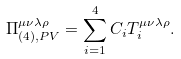<formula> <loc_0><loc_0><loc_500><loc_500>\Pi _ { ( 4 ) , P V } ^ { \mu \nu \lambda \rho } = \sum _ { i = 1 } ^ { 4 } C _ { i } T _ { i } ^ { \mu \nu \lambda \rho } .</formula> 